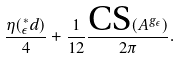<formula> <loc_0><loc_0><loc_500><loc_500>\frac { \eta ( ^ { * } _ { \epsilon } d ) } { 4 } + \frac { 1 } { 1 2 } \frac { \text {CS} ( A ^ { g _ { \epsilon } } ) } { 2 \pi } .</formula> 